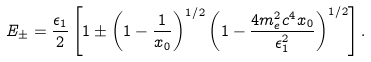<formula> <loc_0><loc_0><loc_500><loc_500>E _ { \pm } = \frac { \epsilon _ { 1 } } { 2 } \left [ 1 \pm \left ( 1 - \frac { 1 } { x _ { 0 } } \right ) ^ { 1 / 2 } \left ( 1 - \frac { 4 m _ { e } ^ { 2 } c ^ { 4 } x _ { 0 } } { \epsilon ^ { 2 } _ { 1 } } \right ) ^ { 1 / 2 } \right ] .</formula> 